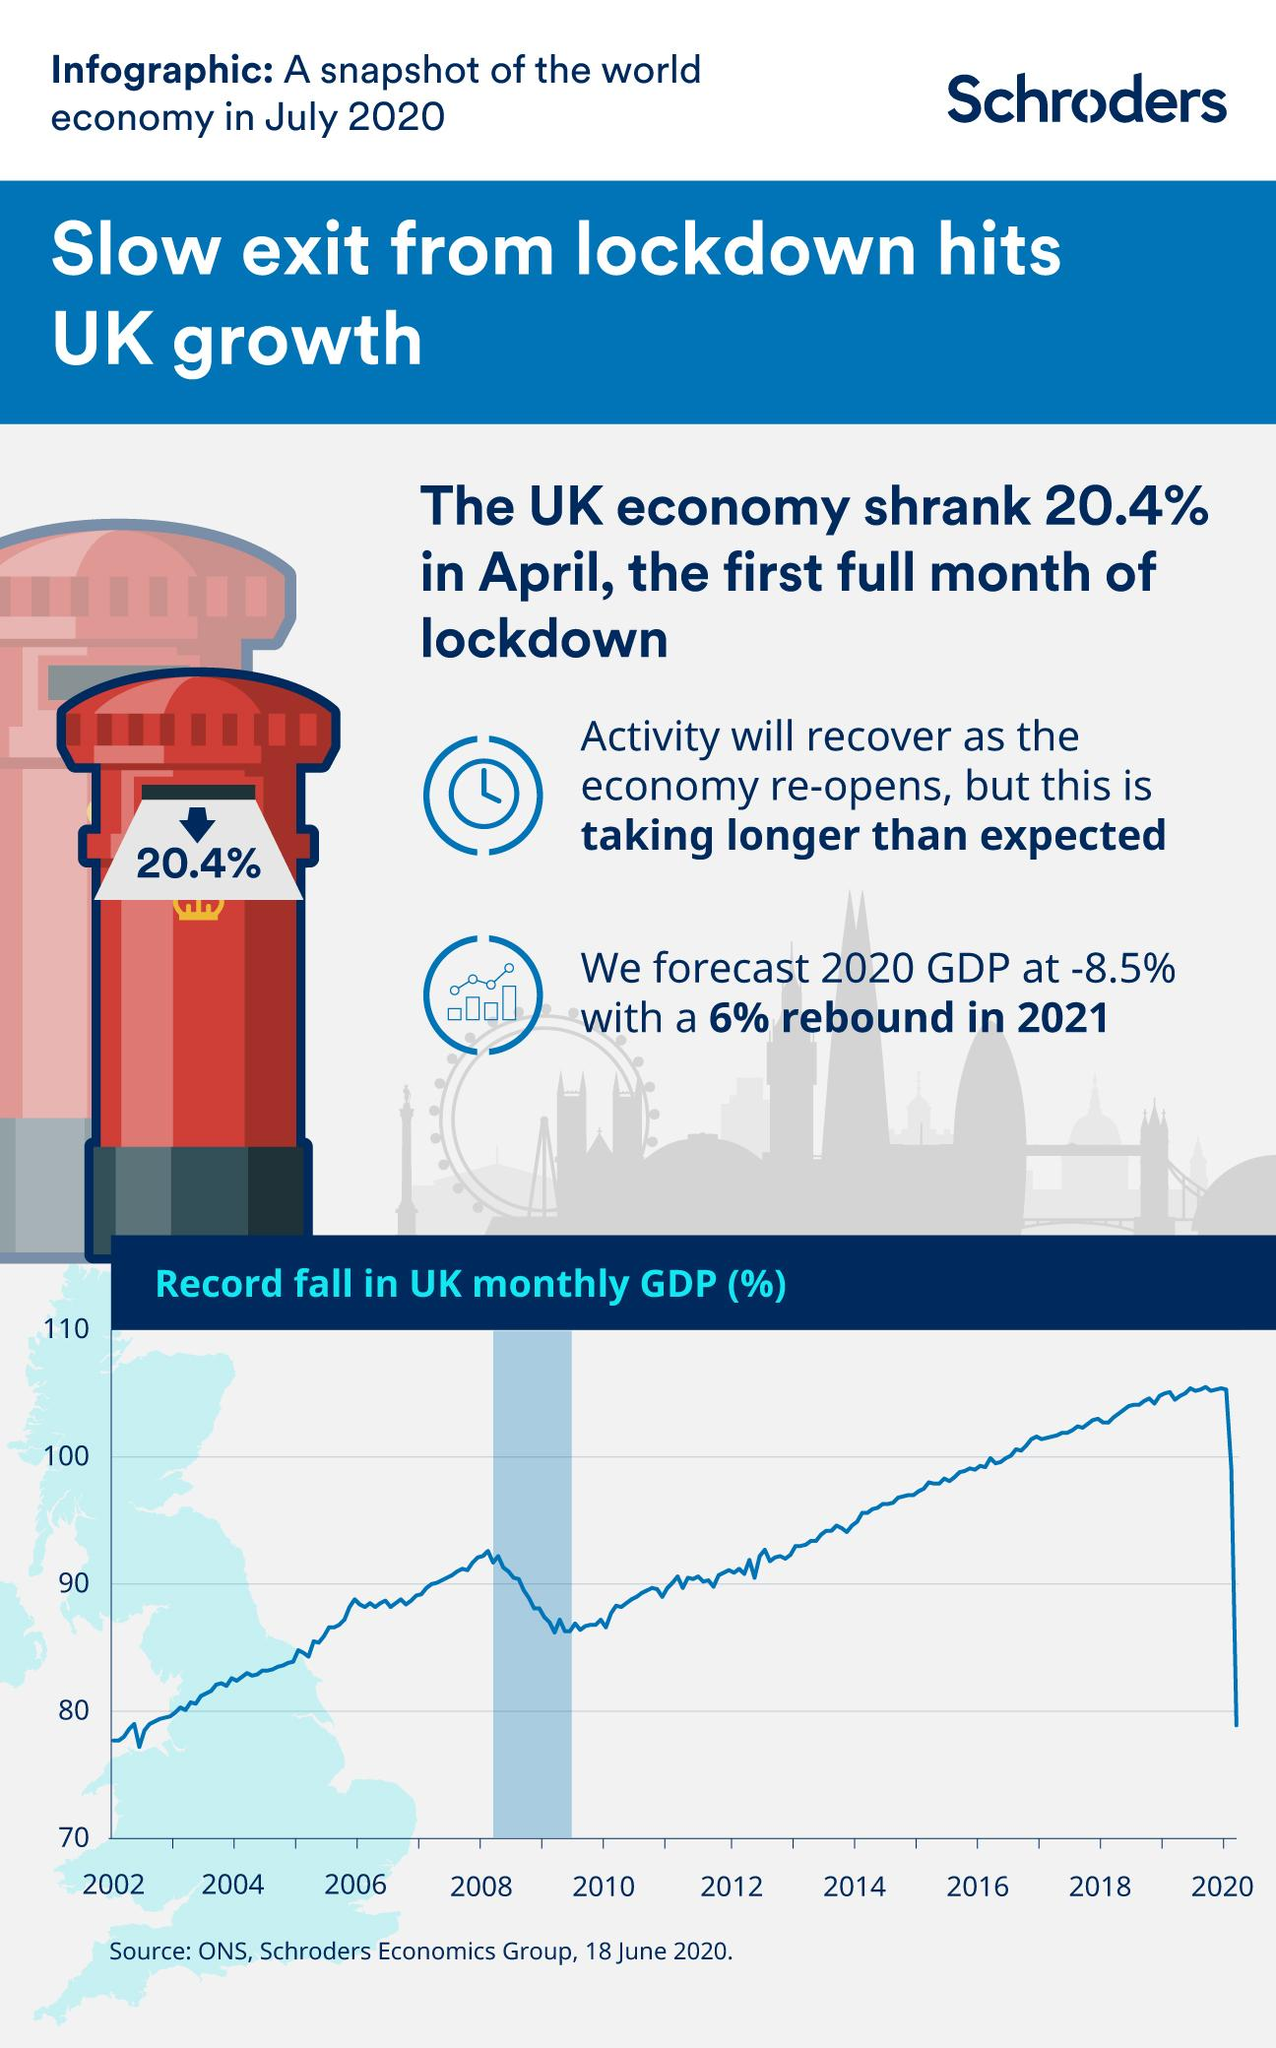List a handful of essential elements in this visual. The UK economy shrank by 79.6% in the last quarter. 